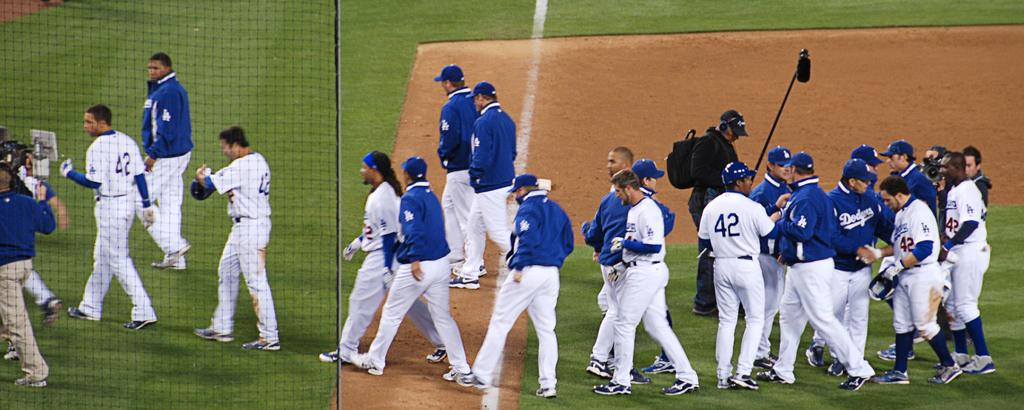<image>
Render a clear and concise summary of the photo. Baseball players on the field including one wearing the number 42. 